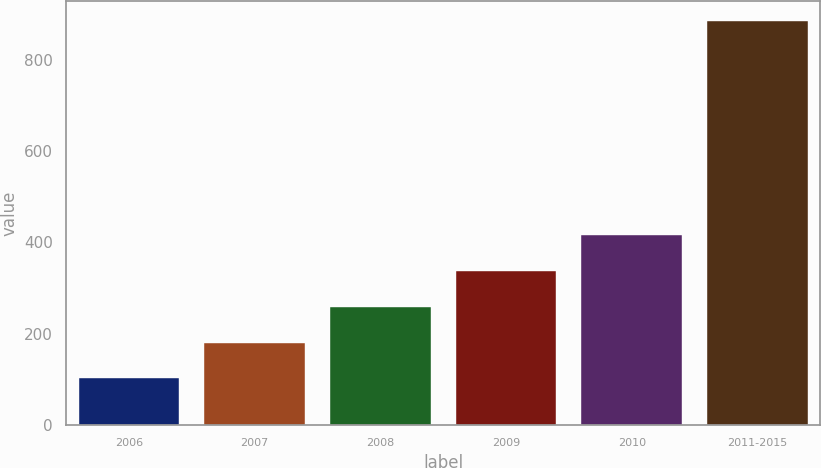<chart> <loc_0><loc_0><loc_500><loc_500><bar_chart><fcel>2006<fcel>2007<fcel>2008<fcel>2009<fcel>2010<fcel>2011-2015<nl><fcel>102<fcel>180.3<fcel>258.6<fcel>336.9<fcel>415.2<fcel>885<nl></chart> 